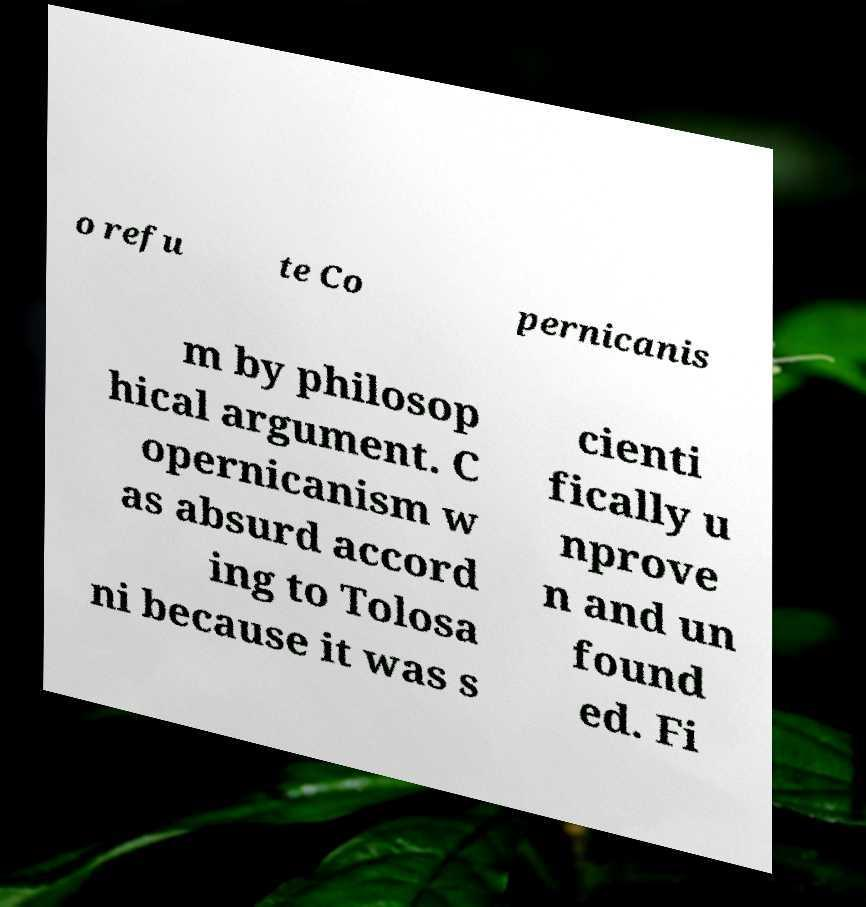Can you read and provide the text displayed in the image?This photo seems to have some interesting text. Can you extract and type it out for me? o refu te Co pernicanis m by philosop hical argument. C opernicanism w as absurd accord ing to Tolosa ni because it was s cienti fically u nprove n and un found ed. Fi 